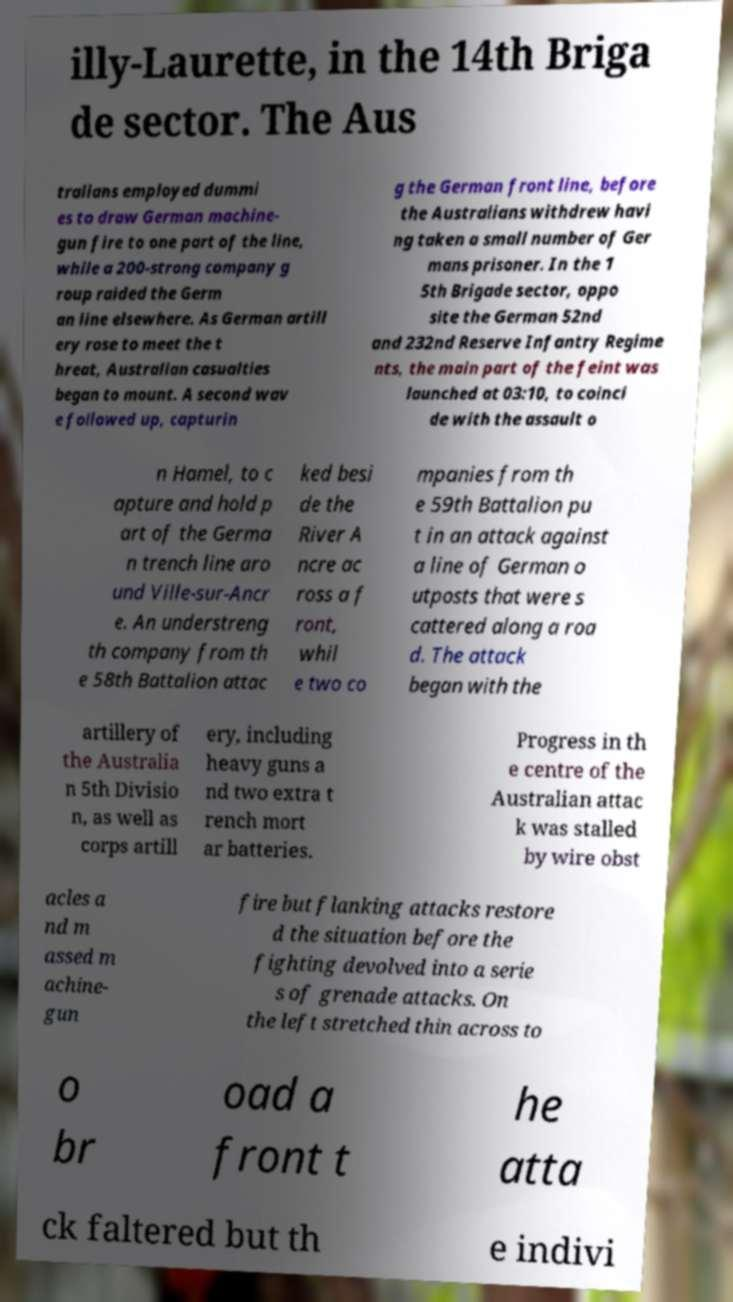I need the written content from this picture converted into text. Can you do that? illy-Laurette, in the 14th Briga de sector. The Aus tralians employed dummi es to draw German machine- gun fire to one part of the line, while a 200-strong company g roup raided the Germ an line elsewhere. As German artill ery rose to meet the t hreat, Australian casualties began to mount. A second wav e followed up, capturin g the German front line, before the Australians withdrew havi ng taken a small number of Ger mans prisoner. In the 1 5th Brigade sector, oppo site the German 52nd and 232nd Reserve Infantry Regime nts, the main part of the feint was launched at 03:10, to coinci de with the assault o n Hamel, to c apture and hold p art of the Germa n trench line aro und Ville-sur-Ancr e. An understreng th company from th e 58th Battalion attac ked besi de the River A ncre ac ross a f ront, whil e two co mpanies from th e 59th Battalion pu t in an attack against a line of German o utposts that were s cattered along a roa d. The attack began with the artillery of the Australia n 5th Divisio n, as well as corps artill ery, including heavy guns a nd two extra t rench mort ar batteries. Progress in th e centre of the Australian attac k was stalled by wire obst acles a nd m assed m achine- gun fire but flanking attacks restore d the situation before the fighting devolved into a serie s of grenade attacks. On the left stretched thin across to o br oad a front t he atta ck faltered but th e indivi 